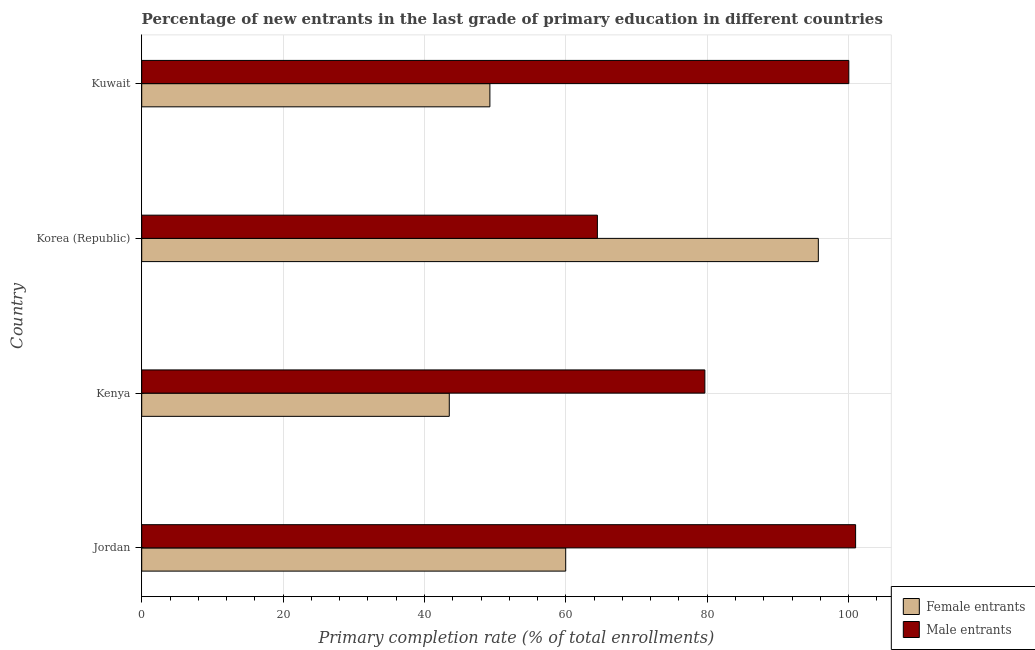How many different coloured bars are there?
Give a very brief answer. 2. Are the number of bars per tick equal to the number of legend labels?
Offer a very short reply. Yes. Are the number of bars on each tick of the Y-axis equal?
Your answer should be compact. Yes. How many bars are there on the 3rd tick from the bottom?
Your answer should be compact. 2. What is the label of the 1st group of bars from the top?
Your answer should be very brief. Kuwait. What is the primary completion rate of male entrants in Korea (Republic)?
Ensure brevity in your answer.  64.46. Across all countries, what is the maximum primary completion rate of female entrants?
Your response must be concise. 95.71. Across all countries, what is the minimum primary completion rate of female entrants?
Give a very brief answer. 43.51. In which country was the primary completion rate of female entrants minimum?
Keep it short and to the point. Kenya. What is the total primary completion rate of female entrants in the graph?
Make the answer very short. 248.45. What is the difference between the primary completion rate of male entrants in Jordan and that in Kenya?
Provide a short and direct response. 21.32. What is the difference between the primary completion rate of male entrants in Kenya and the primary completion rate of female entrants in Jordan?
Give a very brief answer. 19.69. What is the average primary completion rate of male entrants per country?
Keep it short and to the point. 86.28. What is the difference between the primary completion rate of female entrants and primary completion rate of male entrants in Korea (Republic)?
Your response must be concise. 31.25. In how many countries, is the primary completion rate of female entrants greater than 16 %?
Your response must be concise. 4. What is the ratio of the primary completion rate of female entrants in Jordan to that in Kuwait?
Offer a terse response. 1.22. Is the primary completion rate of male entrants in Jordan less than that in Kuwait?
Your answer should be very brief. No. What is the difference between the highest and the second highest primary completion rate of female entrants?
Ensure brevity in your answer.  35.74. What is the difference between the highest and the lowest primary completion rate of male entrants?
Make the answer very short. 36.53. What does the 2nd bar from the top in Kenya represents?
Your answer should be very brief. Female entrants. What does the 2nd bar from the bottom in Jordan represents?
Offer a very short reply. Male entrants. How many bars are there?
Your response must be concise. 8. Are all the bars in the graph horizontal?
Offer a terse response. Yes. How many countries are there in the graph?
Offer a very short reply. 4. Are the values on the major ticks of X-axis written in scientific E-notation?
Your response must be concise. No. Where does the legend appear in the graph?
Your response must be concise. Bottom right. How many legend labels are there?
Provide a succinct answer. 2. How are the legend labels stacked?
Keep it short and to the point. Vertical. What is the title of the graph?
Keep it short and to the point. Percentage of new entrants in the last grade of primary education in different countries. What is the label or title of the X-axis?
Provide a succinct answer. Primary completion rate (% of total enrollments). What is the label or title of the Y-axis?
Your response must be concise. Country. What is the Primary completion rate (% of total enrollments) of Female entrants in Jordan?
Ensure brevity in your answer.  59.98. What is the Primary completion rate (% of total enrollments) in Male entrants in Jordan?
Your answer should be compact. 100.99. What is the Primary completion rate (% of total enrollments) in Female entrants in Kenya?
Provide a short and direct response. 43.51. What is the Primary completion rate (% of total enrollments) of Male entrants in Kenya?
Keep it short and to the point. 79.66. What is the Primary completion rate (% of total enrollments) of Female entrants in Korea (Republic)?
Your response must be concise. 95.71. What is the Primary completion rate (% of total enrollments) of Male entrants in Korea (Republic)?
Keep it short and to the point. 64.46. What is the Primary completion rate (% of total enrollments) of Female entrants in Kuwait?
Your answer should be compact. 49.25. What is the Primary completion rate (% of total enrollments) in Male entrants in Kuwait?
Your answer should be very brief. 100.02. Across all countries, what is the maximum Primary completion rate (% of total enrollments) of Female entrants?
Ensure brevity in your answer.  95.71. Across all countries, what is the maximum Primary completion rate (% of total enrollments) in Male entrants?
Provide a short and direct response. 100.99. Across all countries, what is the minimum Primary completion rate (% of total enrollments) in Female entrants?
Provide a short and direct response. 43.51. Across all countries, what is the minimum Primary completion rate (% of total enrollments) of Male entrants?
Your response must be concise. 64.46. What is the total Primary completion rate (% of total enrollments) in Female entrants in the graph?
Keep it short and to the point. 248.45. What is the total Primary completion rate (% of total enrollments) in Male entrants in the graph?
Ensure brevity in your answer.  345.13. What is the difference between the Primary completion rate (% of total enrollments) of Female entrants in Jordan and that in Kenya?
Provide a short and direct response. 16.47. What is the difference between the Primary completion rate (% of total enrollments) in Male entrants in Jordan and that in Kenya?
Ensure brevity in your answer.  21.32. What is the difference between the Primary completion rate (% of total enrollments) of Female entrants in Jordan and that in Korea (Republic)?
Give a very brief answer. -35.74. What is the difference between the Primary completion rate (% of total enrollments) in Male entrants in Jordan and that in Korea (Republic)?
Ensure brevity in your answer.  36.53. What is the difference between the Primary completion rate (% of total enrollments) of Female entrants in Jordan and that in Kuwait?
Make the answer very short. 10.72. What is the difference between the Primary completion rate (% of total enrollments) in Male entrants in Jordan and that in Kuwait?
Your response must be concise. 0.96. What is the difference between the Primary completion rate (% of total enrollments) in Female entrants in Kenya and that in Korea (Republic)?
Provide a succinct answer. -52.2. What is the difference between the Primary completion rate (% of total enrollments) of Male entrants in Kenya and that in Korea (Republic)?
Keep it short and to the point. 15.2. What is the difference between the Primary completion rate (% of total enrollments) of Female entrants in Kenya and that in Kuwait?
Your answer should be very brief. -5.74. What is the difference between the Primary completion rate (% of total enrollments) in Male entrants in Kenya and that in Kuwait?
Ensure brevity in your answer.  -20.36. What is the difference between the Primary completion rate (% of total enrollments) of Female entrants in Korea (Republic) and that in Kuwait?
Your response must be concise. 46.46. What is the difference between the Primary completion rate (% of total enrollments) of Male entrants in Korea (Republic) and that in Kuwait?
Provide a succinct answer. -35.57. What is the difference between the Primary completion rate (% of total enrollments) in Female entrants in Jordan and the Primary completion rate (% of total enrollments) in Male entrants in Kenya?
Your answer should be very brief. -19.69. What is the difference between the Primary completion rate (% of total enrollments) of Female entrants in Jordan and the Primary completion rate (% of total enrollments) of Male entrants in Korea (Republic)?
Your answer should be compact. -4.48. What is the difference between the Primary completion rate (% of total enrollments) of Female entrants in Jordan and the Primary completion rate (% of total enrollments) of Male entrants in Kuwait?
Offer a terse response. -40.05. What is the difference between the Primary completion rate (% of total enrollments) of Female entrants in Kenya and the Primary completion rate (% of total enrollments) of Male entrants in Korea (Republic)?
Your answer should be very brief. -20.95. What is the difference between the Primary completion rate (% of total enrollments) in Female entrants in Kenya and the Primary completion rate (% of total enrollments) in Male entrants in Kuwait?
Your answer should be very brief. -56.52. What is the difference between the Primary completion rate (% of total enrollments) of Female entrants in Korea (Republic) and the Primary completion rate (% of total enrollments) of Male entrants in Kuwait?
Provide a short and direct response. -4.31. What is the average Primary completion rate (% of total enrollments) of Female entrants per country?
Give a very brief answer. 62.11. What is the average Primary completion rate (% of total enrollments) of Male entrants per country?
Make the answer very short. 86.28. What is the difference between the Primary completion rate (% of total enrollments) in Female entrants and Primary completion rate (% of total enrollments) in Male entrants in Jordan?
Ensure brevity in your answer.  -41.01. What is the difference between the Primary completion rate (% of total enrollments) in Female entrants and Primary completion rate (% of total enrollments) in Male entrants in Kenya?
Your answer should be compact. -36.15. What is the difference between the Primary completion rate (% of total enrollments) of Female entrants and Primary completion rate (% of total enrollments) of Male entrants in Korea (Republic)?
Your response must be concise. 31.25. What is the difference between the Primary completion rate (% of total enrollments) in Female entrants and Primary completion rate (% of total enrollments) in Male entrants in Kuwait?
Offer a terse response. -50.77. What is the ratio of the Primary completion rate (% of total enrollments) of Female entrants in Jordan to that in Kenya?
Provide a short and direct response. 1.38. What is the ratio of the Primary completion rate (% of total enrollments) of Male entrants in Jordan to that in Kenya?
Your answer should be very brief. 1.27. What is the ratio of the Primary completion rate (% of total enrollments) in Female entrants in Jordan to that in Korea (Republic)?
Give a very brief answer. 0.63. What is the ratio of the Primary completion rate (% of total enrollments) in Male entrants in Jordan to that in Korea (Republic)?
Your response must be concise. 1.57. What is the ratio of the Primary completion rate (% of total enrollments) in Female entrants in Jordan to that in Kuwait?
Your answer should be compact. 1.22. What is the ratio of the Primary completion rate (% of total enrollments) of Male entrants in Jordan to that in Kuwait?
Provide a short and direct response. 1.01. What is the ratio of the Primary completion rate (% of total enrollments) in Female entrants in Kenya to that in Korea (Republic)?
Give a very brief answer. 0.45. What is the ratio of the Primary completion rate (% of total enrollments) of Male entrants in Kenya to that in Korea (Republic)?
Provide a succinct answer. 1.24. What is the ratio of the Primary completion rate (% of total enrollments) of Female entrants in Kenya to that in Kuwait?
Keep it short and to the point. 0.88. What is the ratio of the Primary completion rate (% of total enrollments) in Male entrants in Kenya to that in Kuwait?
Your answer should be compact. 0.8. What is the ratio of the Primary completion rate (% of total enrollments) in Female entrants in Korea (Republic) to that in Kuwait?
Give a very brief answer. 1.94. What is the ratio of the Primary completion rate (% of total enrollments) in Male entrants in Korea (Republic) to that in Kuwait?
Give a very brief answer. 0.64. What is the difference between the highest and the second highest Primary completion rate (% of total enrollments) of Female entrants?
Your response must be concise. 35.74. What is the difference between the highest and the second highest Primary completion rate (% of total enrollments) of Male entrants?
Give a very brief answer. 0.96. What is the difference between the highest and the lowest Primary completion rate (% of total enrollments) of Female entrants?
Offer a terse response. 52.2. What is the difference between the highest and the lowest Primary completion rate (% of total enrollments) of Male entrants?
Your answer should be compact. 36.53. 